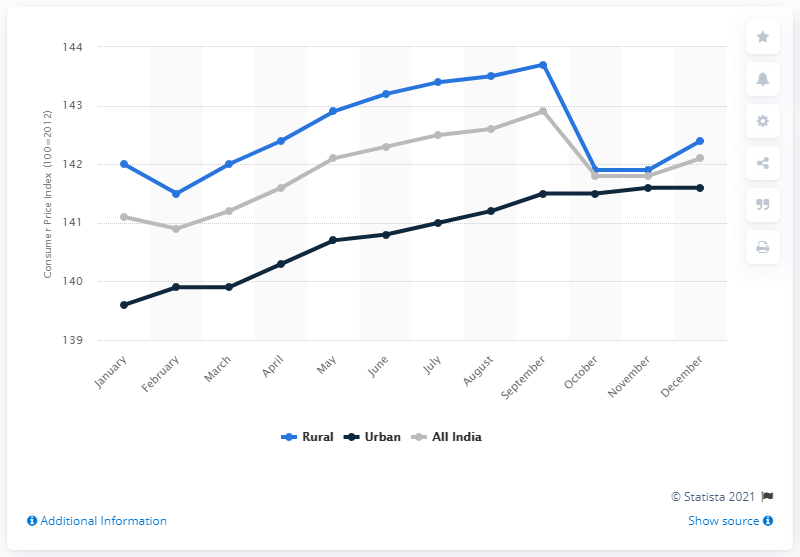Highlight a few significant elements in this photo. In December 2018, the Consumer Price Index for milk and milk products was 142.4. 